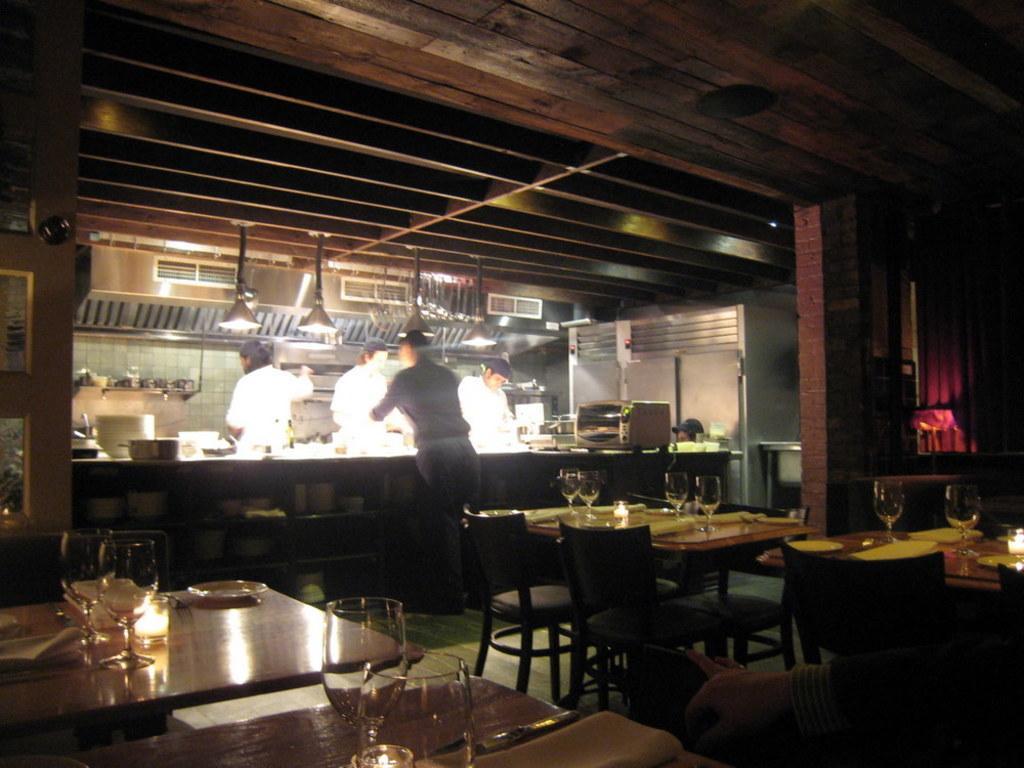How would you summarize this image in a sentence or two? The photo is clicked inside a restaurant. There are chairs around tables. On the table there are glasses, plates, table mat. In the background there is kitchen ,microwave. Few people are there in the kitchen. One person is standing outside the kitchen counter. 